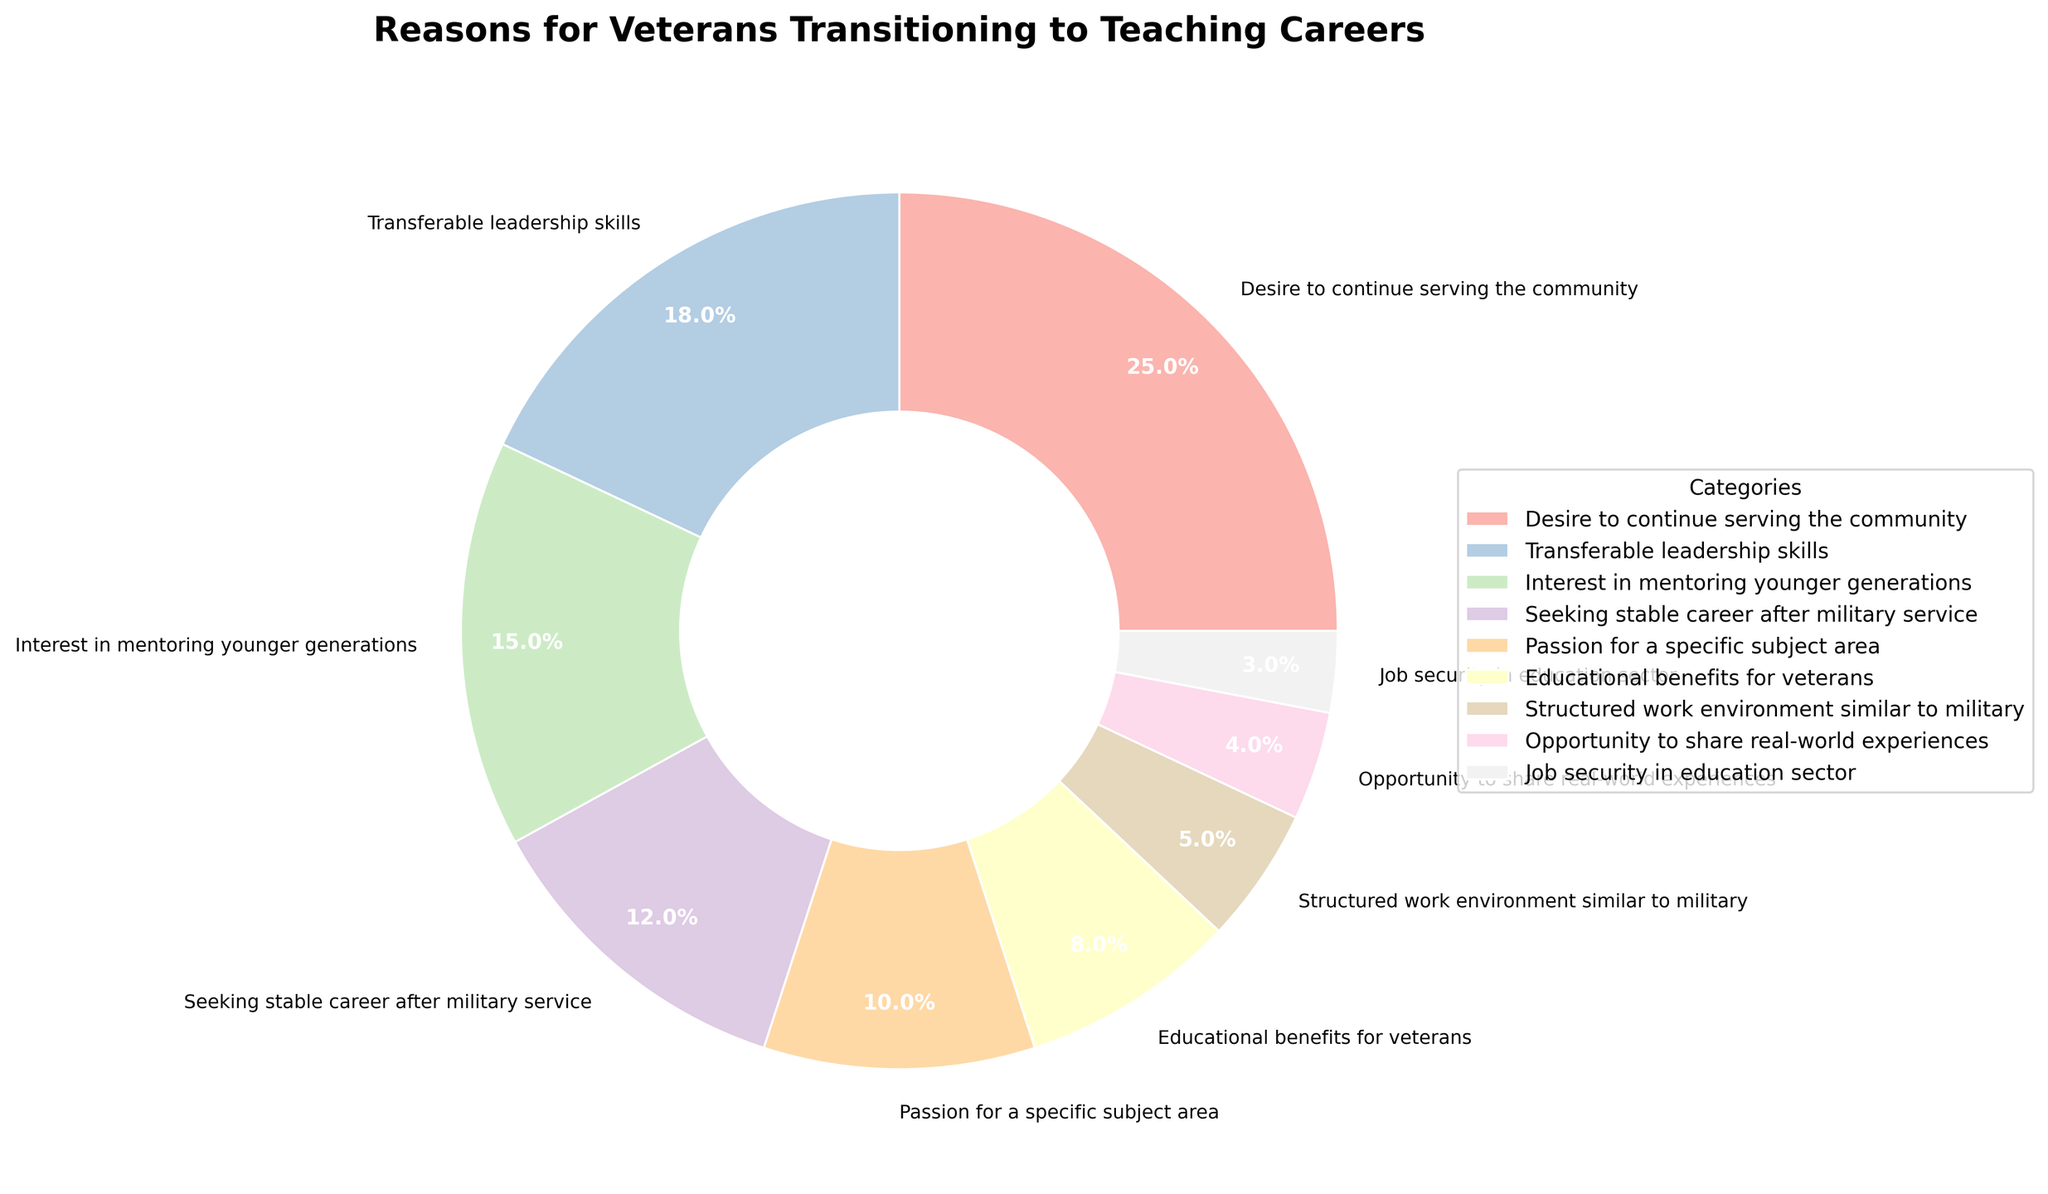What percentage of veterans transitioned to teaching due to a desire to continue serving the community? Referring to the figure, the slice labeled "Desire to continue serving the community" has a percentage value attached.
Answer: 25% Which reason has a higher percentage, seeking stable career after military service or passion for a specific subject area? Compare the percentages for "Seeking stable career after military service" (12%) and "Passion for a specific subject area" (10%) as shown in the figure.
Answer: Seeking stable career after military service What is the combined percentage for veterans transitioning to teaching due to interest in mentoring younger generations and educational benefits for veterans? Look at the percentages for "Interest in mentoring younger generations" (15%) and "Educational benefits for veterans" (8%) and sum them up: 15% + 8% = 23%
Answer: 23% Which category has the smallest percentage, and what is that percentage? The smallest percentage is associated with "Job security in education sector" at 3%.
Answer: Job security in education sector, 3% How much greater is the percentage of veterans who transition to teaching for transferable leadership skills compared to those seeking a structured work environment similar to the military? Subtract the percentage for "Structured work environment similar to military" (5%) from "Transferable leadership skills" (18%): 18% - 5% = 13%
Answer: 13% Identifying by color, what is the coloration of the largest slice in the pie chart? The largest slice (representing "Desire to continue serving the community" at 25%) is colored in a distinct shade from the Pastel1 colormap.
Answer: A pastel color slice Which reasons have percentages in the single digits, and what are their ranges? Look at the categories with percentages less than 10%, which are "Educational benefits for veterans" (8%), "Structured work environment similar to military" (5%), "Opportunity to share real-world experiences" (4%), and "Job security in education sector" (3%). The range for these values is 3% to 8%.
Answer: Educational benefits for veterans, Structured work environment similar to military, Opportunity to share real-world experiences, Job security in education sector; 3%-8% What is the average percentage for the top three categories? The top three categories are "Desire to continue serving the community" (25%), "Transferable leadership skills" (18%), and "Interest in mentoring younger generations" (15%). To find the average: (25% + 18% + 15%) / 3 = 58% / 3 ≈ 19.3%
Answer: 19.3% If you combine the percentages for passion for a specific subject area, opportunity to share real-world experiences, and job security in the education sector, what do you get? Sum the percentages for "Passion for a specific subject area" (10%), "Opportunity to share real-world experiences" (4%), and "Job security in education sector" (3%): 10% + 4% + 3% = 17%
Answer: 17% How many more percent of veterans are motivated by a desire to continue serving the community compared to those seeking a structured work environment similar to the military? Subtract the percentage for "Structured work environment similar to military" (5%) from "Desire to continue serving the community" (25%): 25% - 5% = 20%
Answer: 20% 